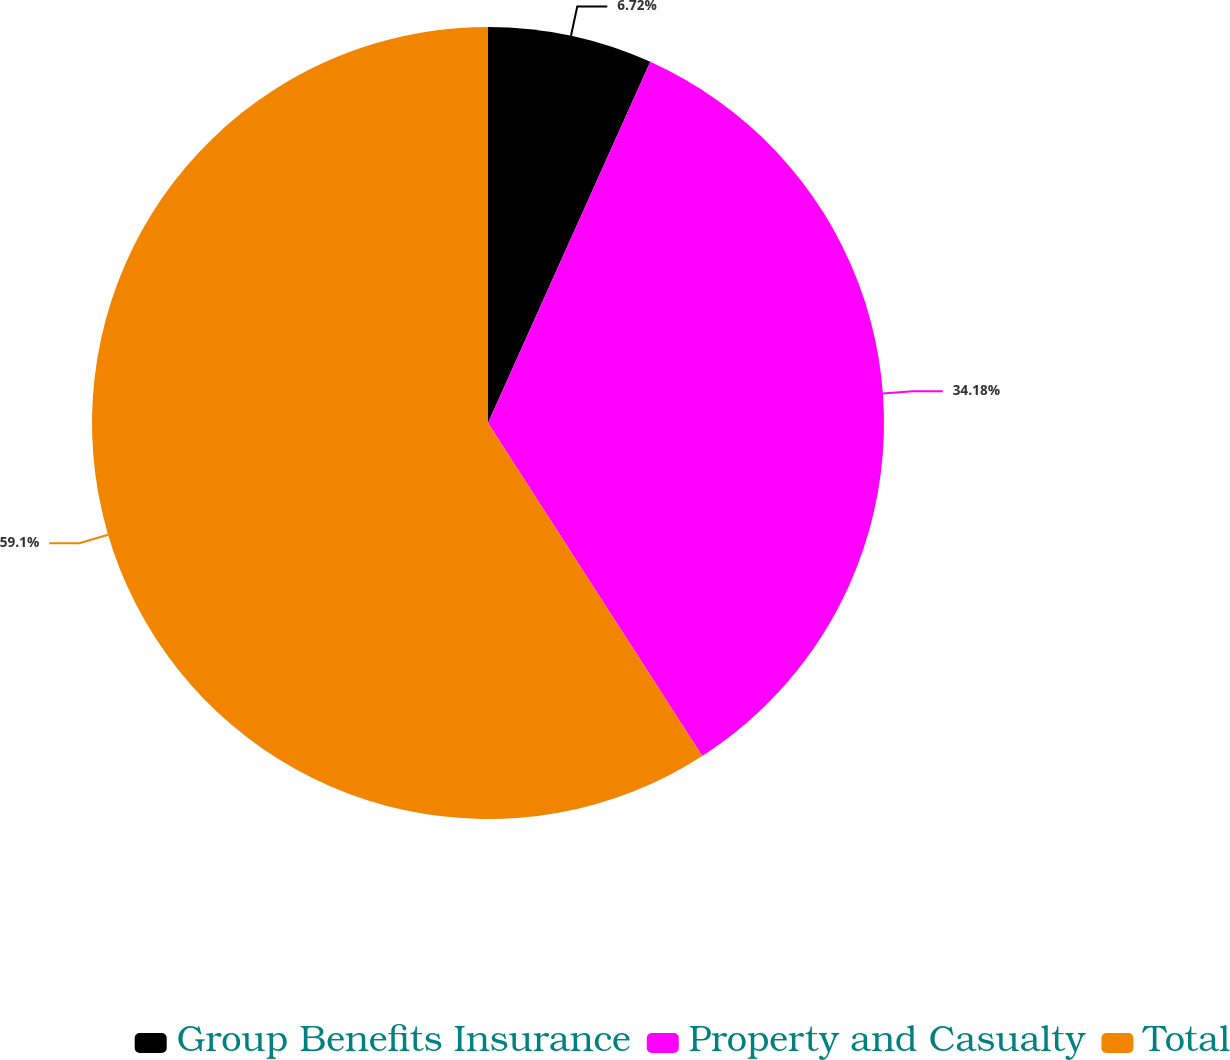Convert chart to OTSL. <chart><loc_0><loc_0><loc_500><loc_500><pie_chart><fcel>Group Benefits Insurance<fcel>Property and Casualty<fcel>Total<nl><fcel>6.72%<fcel>34.18%<fcel>59.1%<nl></chart> 